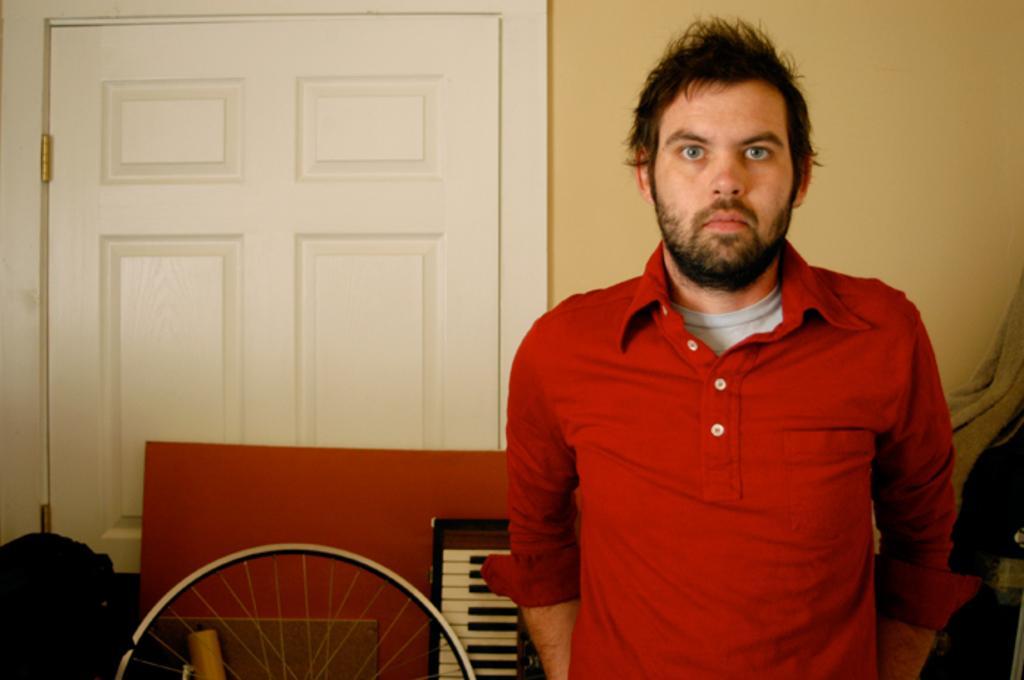Describe this image in one or two sentences. In this picture we can see man standing wore red color T-Shirt and in the background we can see door,bag, wheel, piano, wall. 